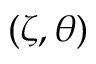Convert formula to latex. <formula><loc_0><loc_0><loc_500><loc_500>( \zeta , \theta )</formula> 